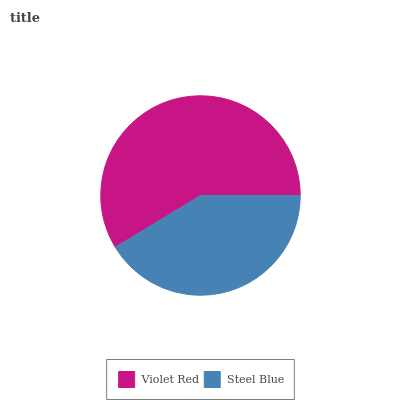Is Steel Blue the minimum?
Answer yes or no. Yes. Is Violet Red the maximum?
Answer yes or no. Yes. Is Steel Blue the maximum?
Answer yes or no. No. Is Violet Red greater than Steel Blue?
Answer yes or no. Yes. Is Steel Blue less than Violet Red?
Answer yes or no. Yes. Is Steel Blue greater than Violet Red?
Answer yes or no. No. Is Violet Red less than Steel Blue?
Answer yes or no. No. Is Violet Red the high median?
Answer yes or no. Yes. Is Steel Blue the low median?
Answer yes or no. Yes. Is Steel Blue the high median?
Answer yes or no. No. Is Violet Red the low median?
Answer yes or no. No. 